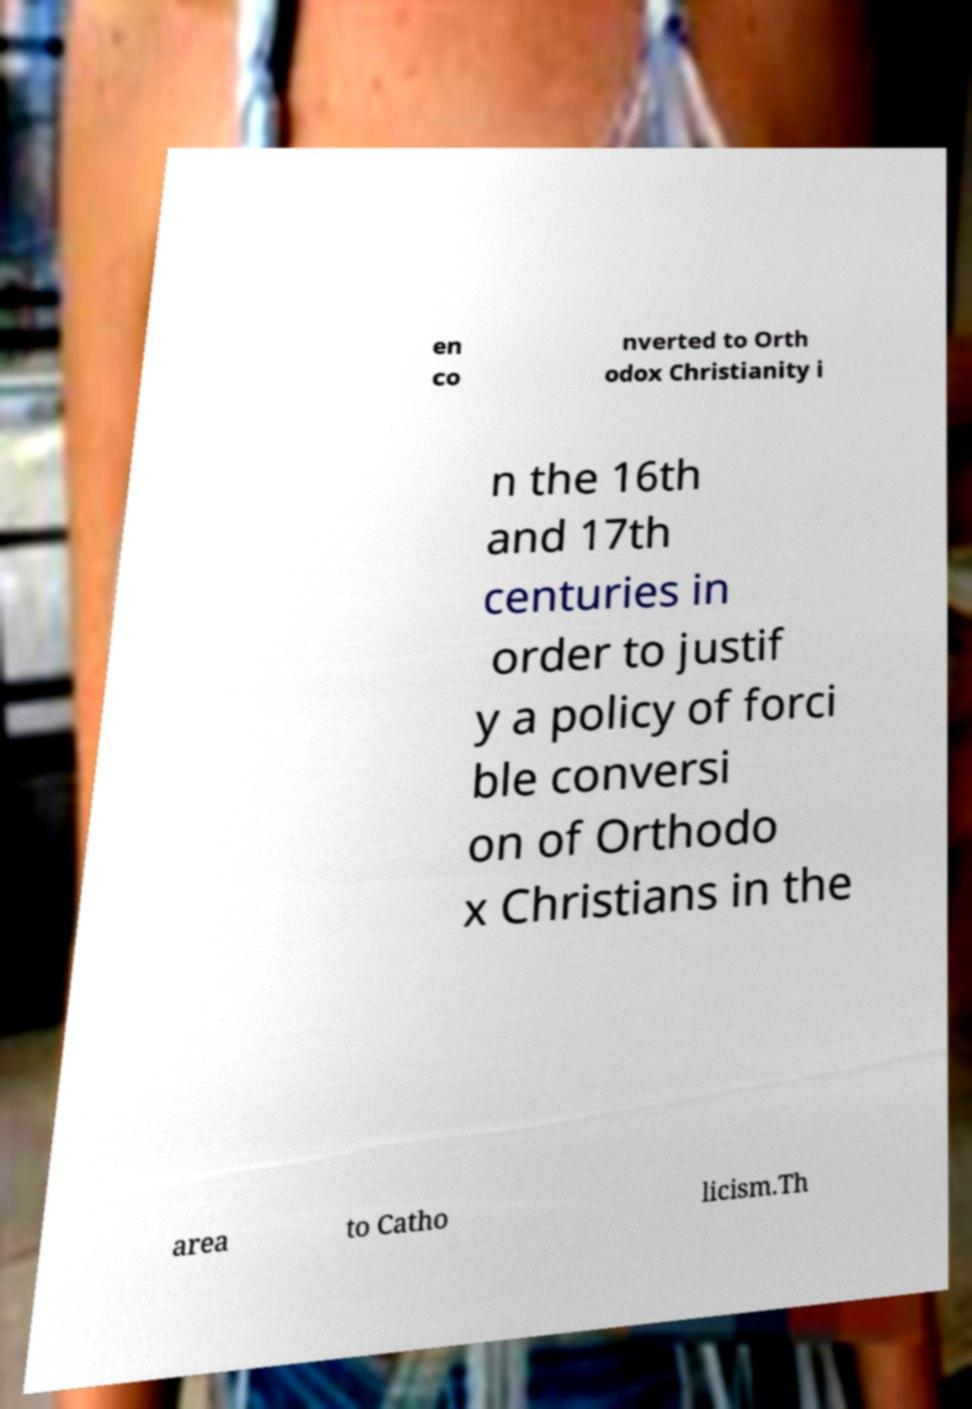I need the written content from this picture converted into text. Can you do that? en co nverted to Orth odox Christianity i n the 16th and 17th centuries in order to justif y a policy of forci ble conversi on of Orthodo x Christians in the area to Catho licism.Th 